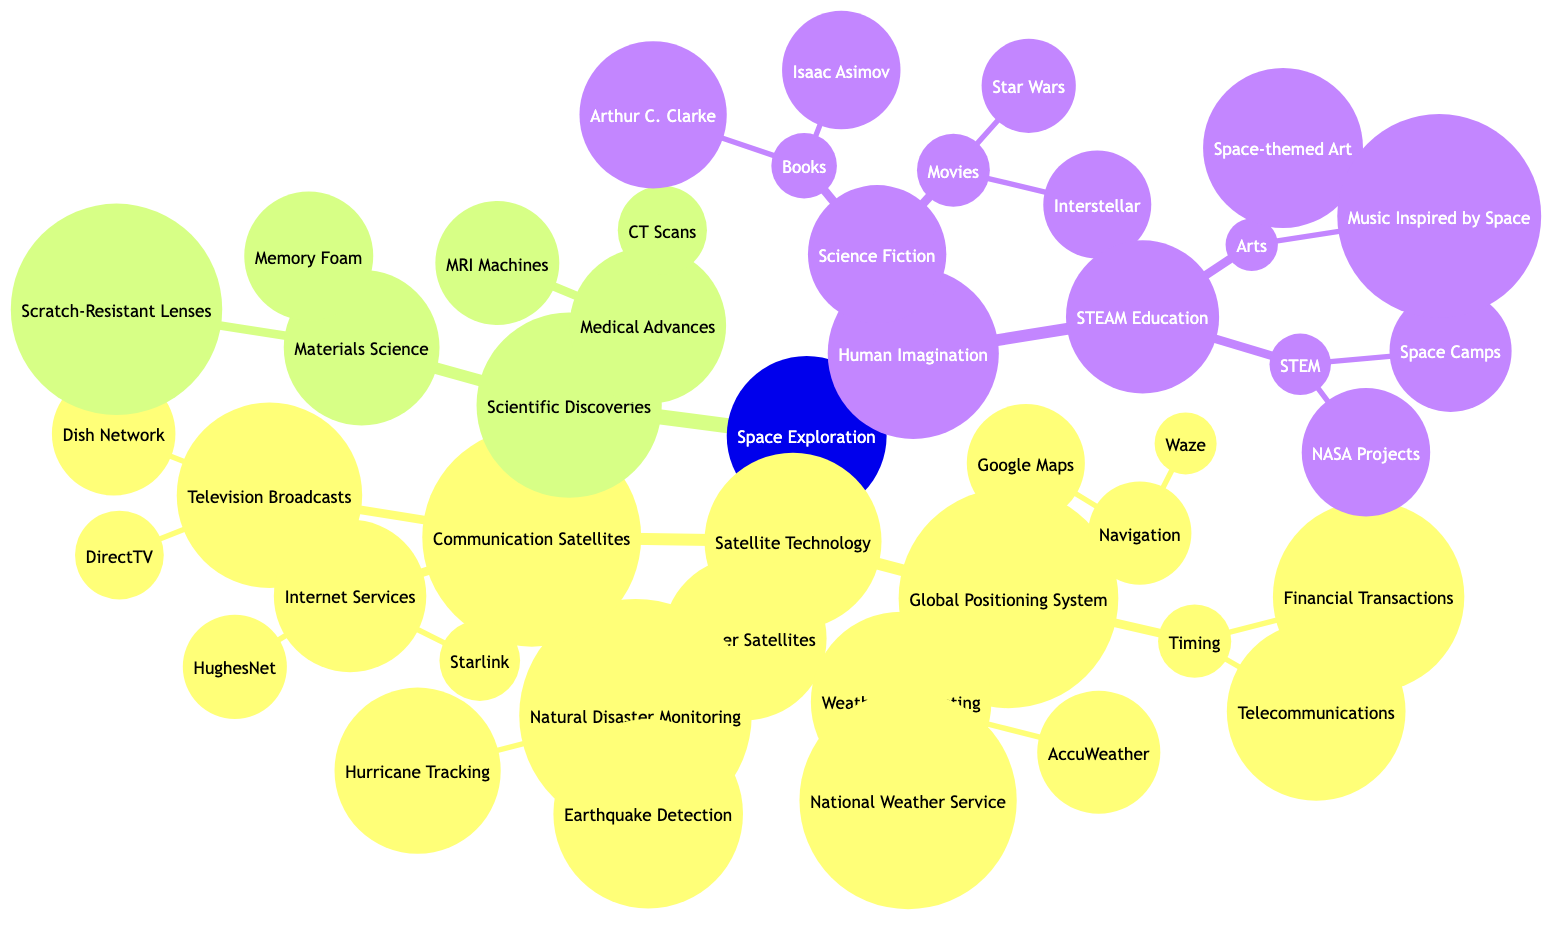What is the main title of the concept map? The title is prominently displayed at the top of the diagram, summarizing the central theme of the concept map.
Answer: The Impact of Space Exploration on Daily Life: From Satellite Technology to Human Imagination How many main categories are there under Space Exploration? The main node "Space Exploration" has three primary child nodes: Satellite Technology, Scientific Discoveries, and Human Imagination, which can be counted directly under it.
Answer: 3 What technology is associated with Communication Satellites? The diagram shows two main types of services associated with Communication Satellites: Television Broadcasts and Internet Services, which can be directly identified from the children of this node.
Answer: Television Broadcasts and Internet Services Which scientific advance relates to CT Scans? CT Scans are listed under the Medical Advances node within the Scientific Discoveries category, establishing a direct relationship.
Answer: Medical Advances What do Weather Satellites monitor for natural disasters? The children of Weather Satellites include Natural Disaster Monitoring, which further breaks down into Hurricane Tracking and Earthquake Detection, showing their role directly in monitoring disasters.
Answer: Hurricane Tracking and Earthquake Detection How many authors are mentioned under Science Fiction? The Books category under Science Fiction lists two authors: Isaac Asimov and Arthur C. Clarke, allowing for a complete count of individual mentions here.
Answer: 2 What is the relationship between Satellite Technology and Navigation? Satellite Technology is a parent node that includes Global Positioning System as a child node, which further divides into Navigation, showcasing the hierarchical nature of the relationships within the concept map.
Answer: Satellite Technology includes Navigation Which type of education is highlighted under Human Imagination? The STEAM Education component under Human Imagination explicitly mentions STEM and Arts as two main subcategories, pinpointing the educational focus areas presented.
Answer: STEAM Education What type of lenses are mentioned in the Materials Science category? Scratch-Resistant Lenses is specifically listed under the Materials Science node, providing a direct reference to the type of lens technology derived from scientific exploration.
Answer: Scratch-Resistant Lenses What literary genre influences Human Imagination related to space? The Science Fiction node depicts both Books and Movies as influences on Human Imagination, aligning the genre directly with cultural impacts from space exploration.
Answer: Science Fiction 